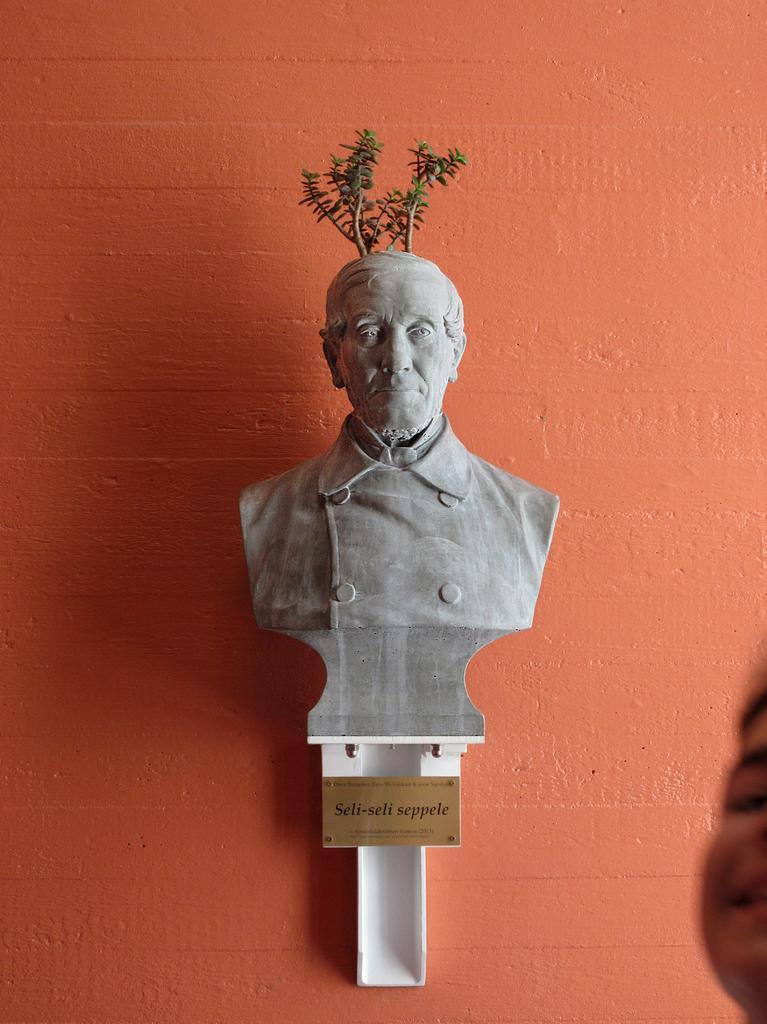In one or two sentences, can you explain what this image depicts? In this image we can see a statue and a board on which some text is written. On the top of the statue we can see a plant. In the background of the image we can see a wall which is in orange color. 